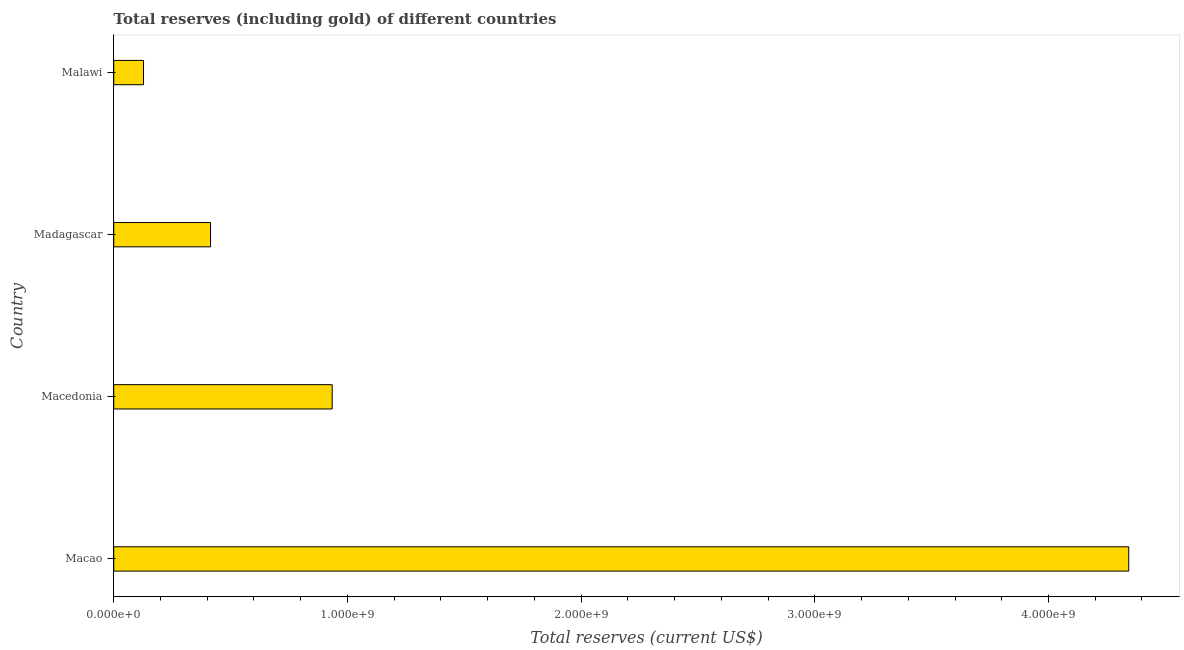Does the graph contain any zero values?
Provide a short and direct response. No. What is the title of the graph?
Give a very brief answer. Total reserves (including gold) of different countries. What is the label or title of the X-axis?
Provide a short and direct response. Total reserves (current US$). What is the total reserves (including gold) in Madagascar?
Your answer should be compact. 4.14e+08. Across all countries, what is the maximum total reserves (including gold)?
Keep it short and to the point. 4.34e+09. Across all countries, what is the minimum total reserves (including gold)?
Your answer should be very brief. 1.27e+08. In which country was the total reserves (including gold) maximum?
Your response must be concise. Macao. In which country was the total reserves (including gold) minimum?
Make the answer very short. Malawi. What is the sum of the total reserves (including gold)?
Provide a short and direct response. 5.82e+09. What is the difference between the total reserves (including gold) in Madagascar and Malawi?
Keep it short and to the point. 2.87e+08. What is the average total reserves (including gold) per country?
Your answer should be very brief. 1.45e+09. What is the median total reserves (including gold)?
Provide a succinct answer. 6.75e+08. In how many countries, is the total reserves (including gold) greater than 4000000000 US$?
Your response must be concise. 1. What is the ratio of the total reserves (including gold) in Macao to that in Malawi?
Your answer should be compact. 34.09. What is the difference between the highest and the second highest total reserves (including gold)?
Your response must be concise. 3.41e+09. What is the difference between the highest and the lowest total reserves (including gold)?
Your answer should be compact. 4.22e+09. In how many countries, is the total reserves (including gold) greater than the average total reserves (including gold) taken over all countries?
Offer a very short reply. 1. How many countries are there in the graph?
Your answer should be very brief. 4. Are the values on the major ticks of X-axis written in scientific E-notation?
Make the answer very short. Yes. What is the Total reserves (current US$) in Macao?
Provide a short and direct response. 4.34e+09. What is the Total reserves (current US$) of Macedonia?
Give a very brief answer. 9.35e+08. What is the Total reserves (current US$) in Madagascar?
Your answer should be very brief. 4.14e+08. What is the Total reserves (current US$) in Malawi?
Your answer should be compact. 1.27e+08. What is the difference between the Total reserves (current US$) in Macao and Macedonia?
Offer a very short reply. 3.41e+09. What is the difference between the Total reserves (current US$) in Macao and Madagascar?
Your answer should be very brief. 3.93e+09. What is the difference between the Total reserves (current US$) in Macao and Malawi?
Offer a very short reply. 4.22e+09. What is the difference between the Total reserves (current US$) in Macedonia and Madagascar?
Give a very brief answer. 5.20e+08. What is the difference between the Total reserves (current US$) in Macedonia and Malawi?
Ensure brevity in your answer.  8.07e+08. What is the difference between the Total reserves (current US$) in Madagascar and Malawi?
Your answer should be compact. 2.87e+08. What is the ratio of the Total reserves (current US$) in Macao to that in Macedonia?
Make the answer very short. 4.65. What is the ratio of the Total reserves (current US$) in Macao to that in Madagascar?
Your answer should be very brief. 10.48. What is the ratio of the Total reserves (current US$) in Macao to that in Malawi?
Keep it short and to the point. 34.09. What is the ratio of the Total reserves (current US$) in Macedonia to that in Madagascar?
Your answer should be very brief. 2.26. What is the ratio of the Total reserves (current US$) in Macedonia to that in Malawi?
Your answer should be very brief. 7.34. What is the ratio of the Total reserves (current US$) in Madagascar to that in Malawi?
Make the answer very short. 3.25. 